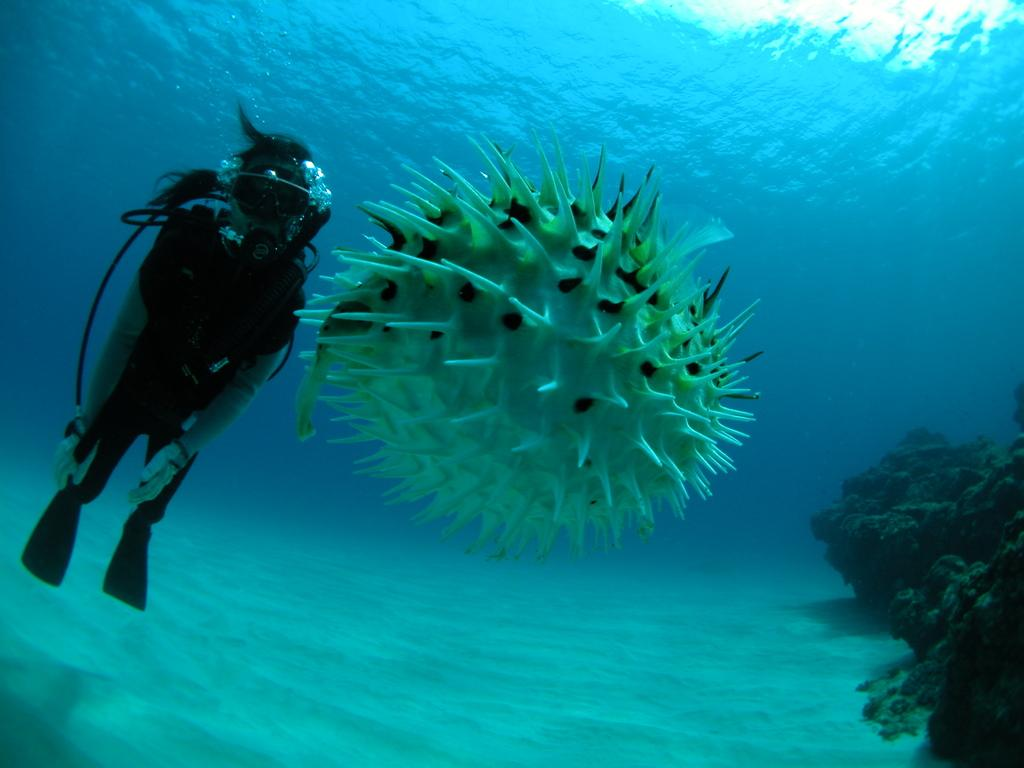What type of animal can be seen in the image? There is a water animal underwater in the image. Can you describe the person on the left side of the image? There is a person on the left side of the image, but no specific details about their appearance are provided. What type of terrain is visible in the background of the image? There is sand and water visible in the background of the image. What type of metal can be seen in the hair of the person in the image? There is no mention of hair or metal in the image, as the focus is on the water animal and the person's presence. 